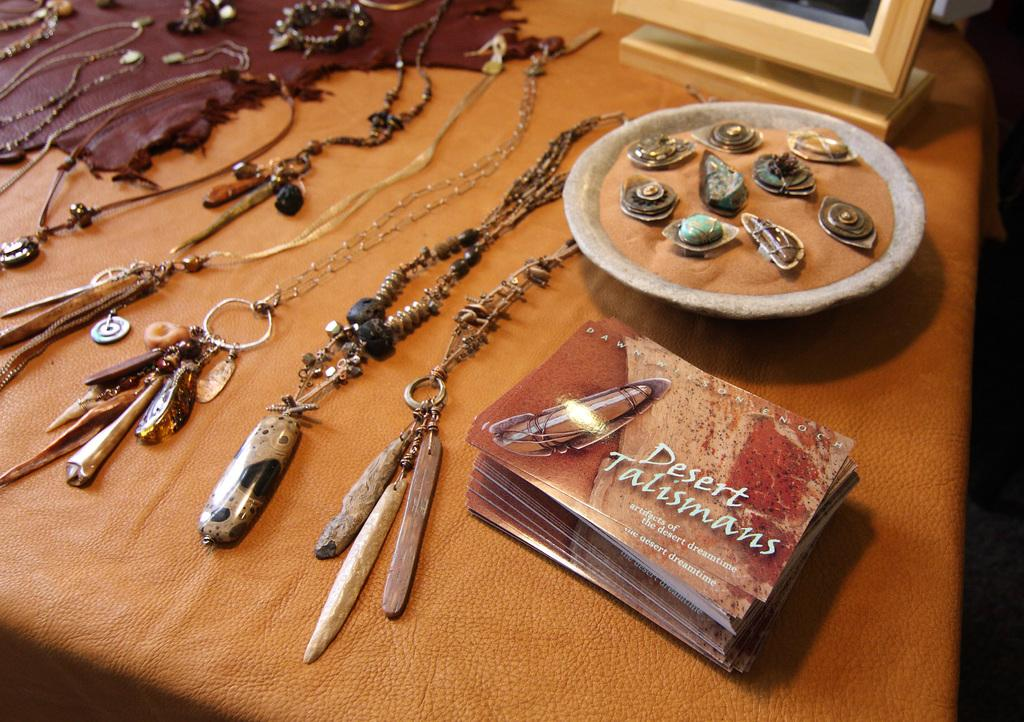<image>
Give a short and clear explanation of the subsequent image. A stack of cards saying Desert Talismans sits next to several pieces of jewelry on a table. 